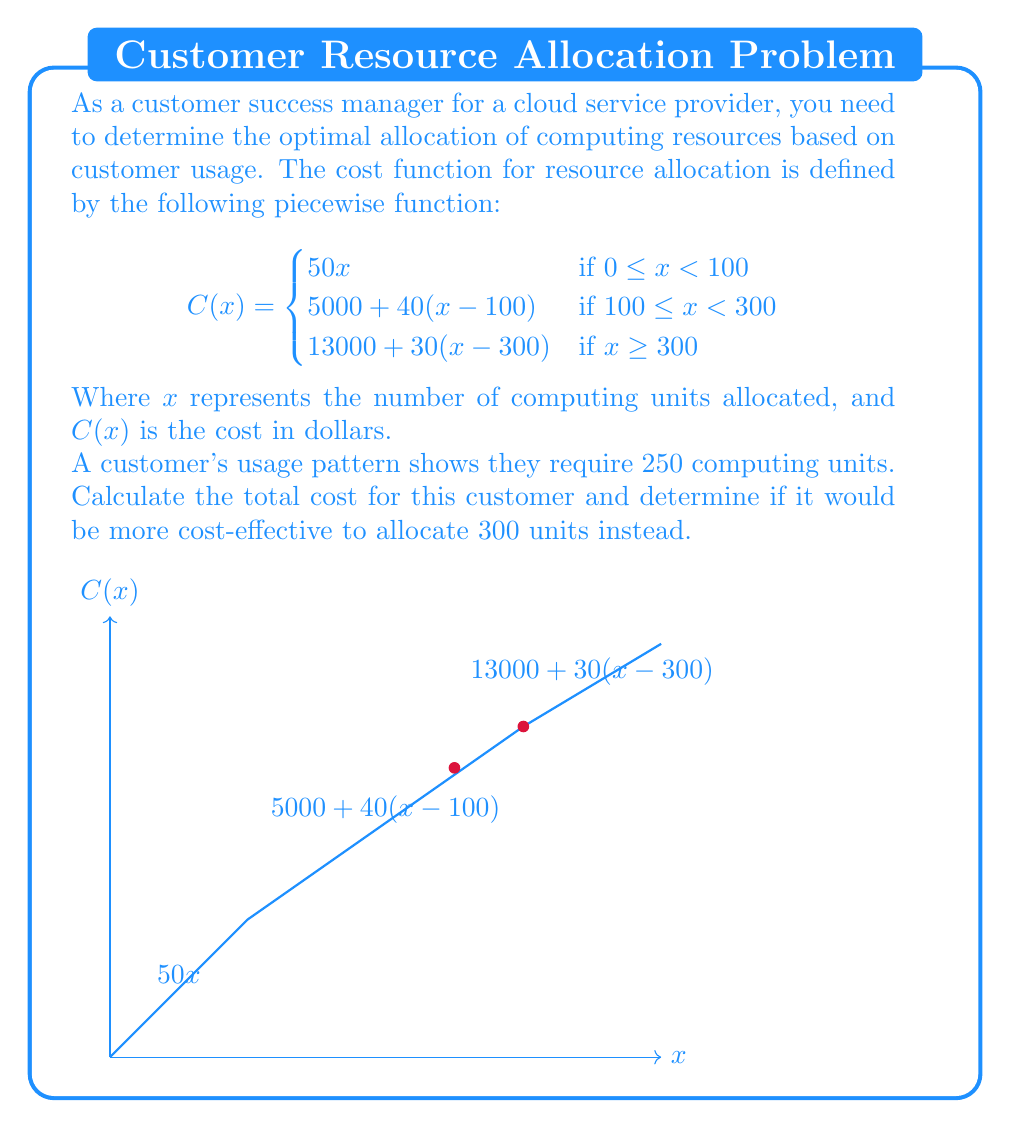Teach me how to tackle this problem. Let's approach this problem step-by-step:

1) First, we need to determine which piece of the function applies to 250 computing units:

   250 falls in the range 100 ≤ x < 300, so we use the second piece of the function.

2) Calculate the cost for 250 units:
   $$C(250) = 5000 + 40(250-100)$$
   $$= 5000 + 40(150)$$
   $$= 5000 + 6000$$
   $$= 11000$$

3) Now, let's calculate the cost for 300 units:
   $$C(300) = 13000 + 30(300-300)$$
   $$= 13000 + 30(0)$$
   $$= 13000$$

4) Compare the costs:
   250 units cost $11,000
   300 units cost $13,000

5) Determine if it's more cost-effective to allocate 300 units:
   Since 300 units cost $2,000 more than 250 units, it is not more cost-effective to allocate 300 units.
Answer: $11,000; No 